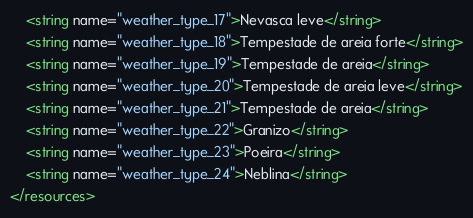Convert code to text. <code><loc_0><loc_0><loc_500><loc_500><_XML_>    <string name="weather_type_17">Nevasca leve</string>
    <string name="weather_type_18">Tempestade de areia forte</string>
    <string name="weather_type_19">Tempestade de areia</string>
    <string name="weather_type_20">Tempestade de areia leve</string>
    <string name="weather_type_21">Tempestade de areia</string>
    <string name="weather_type_22">Granizo</string>
    <string name="weather_type_23">Poeira</string>
    <string name="weather_type_24">Neblina</string>
</resources>
</code> 